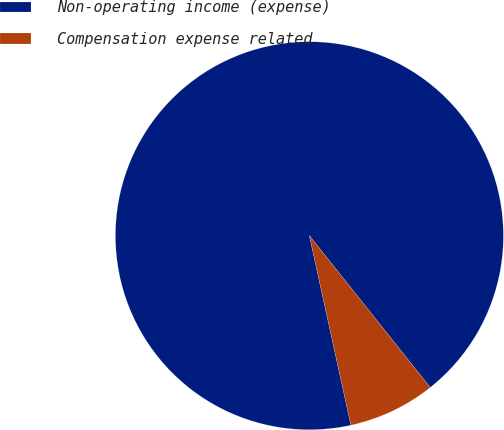<chart> <loc_0><loc_0><loc_500><loc_500><pie_chart><fcel>Non-operating income (expense)<fcel>Compensation expense related<nl><fcel>92.73%<fcel>7.27%<nl></chart> 